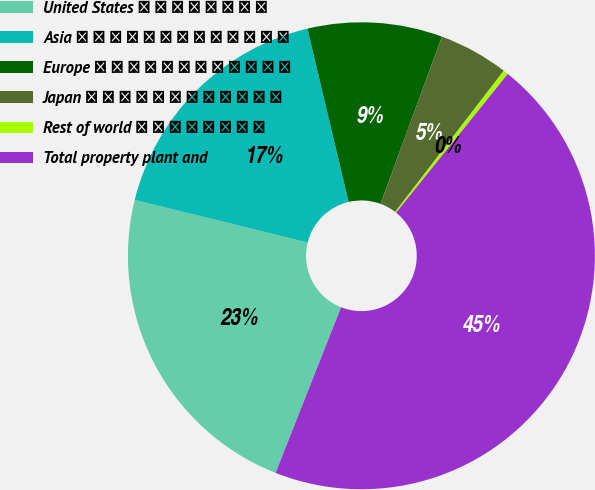Convert chart. <chart><loc_0><loc_0><loc_500><loc_500><pie_chart><fcel>United States � � � � � � � �<fcel>Asia � � � � � � � � � � � � �<fcel>Europe � � � � � � � � � � � �<fcel>Japan � � � � � � � � � � � �<fcel>Rest of world � � � � � � � �<fcel>Total property plant and<nl><fcel>22.85%<fcel>17.44%<fcel>9.32%<fcel>4.83%<fcel>0.35%<fcel>45.2%<nl></chart> 